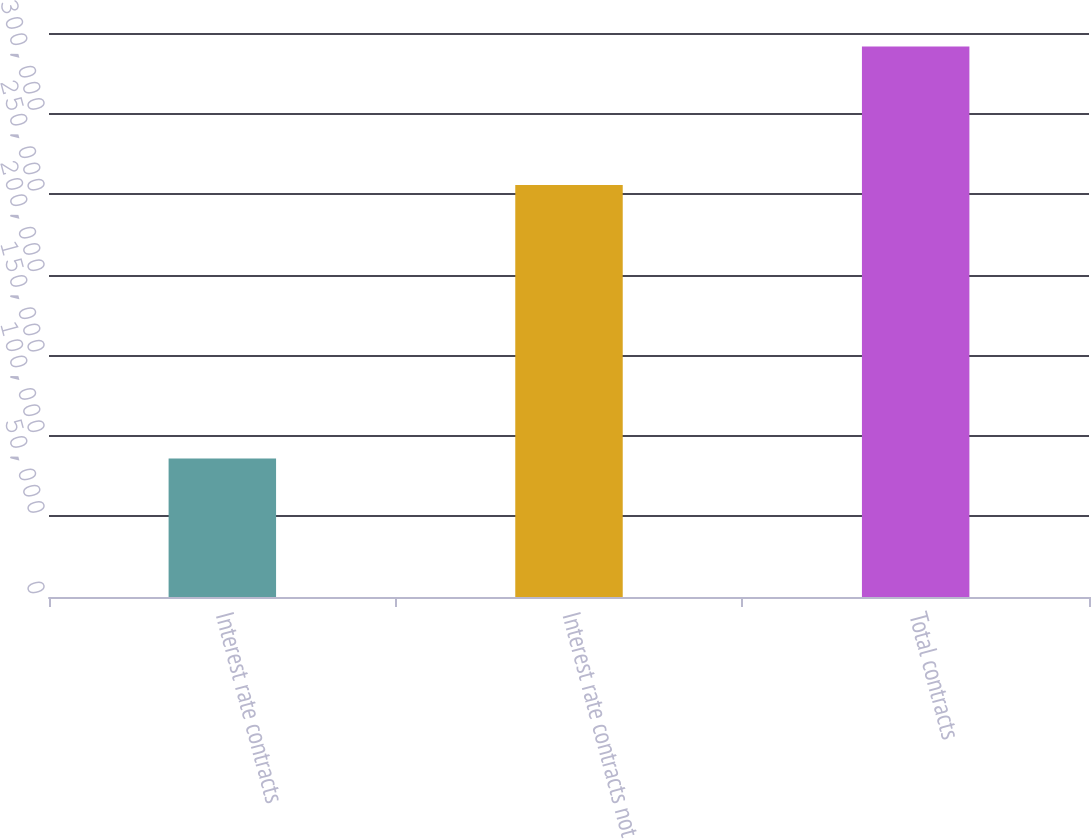Convert chart. <chart><loc_0><loc_0><loc_500><loc_500><bar_chart><fcel>Interest rate contracts<fcel>Interest rate contracts not<fcel>Total contracts<nl><fcel>85984<fcel>255692<fcel>341676<nl></chart> 